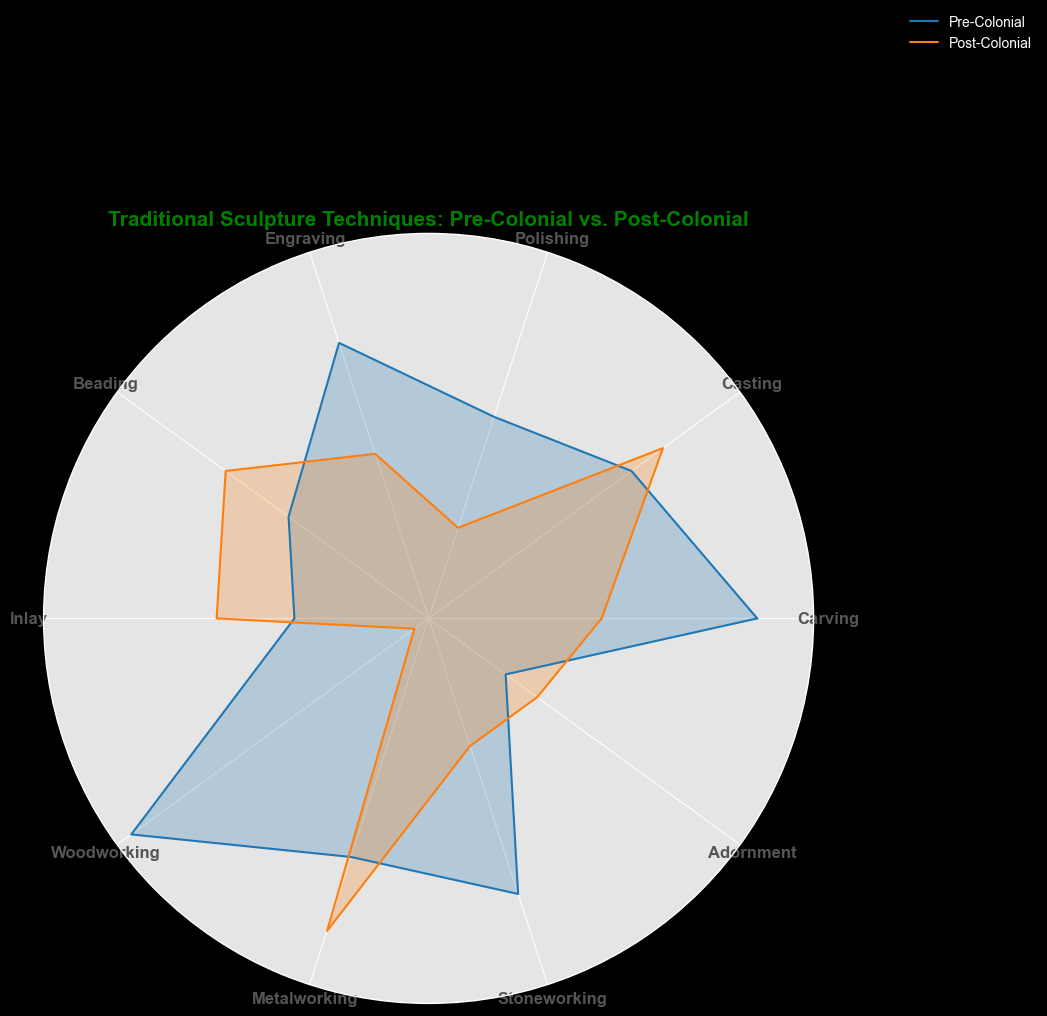Which technique has the greatest difference between the Pre-Colonial and Post-Colonial periods? By examining the radar chart, we compare the values for each technique in both periods. The greatest difference is observed in Woodworking (Pre-Colonial: 95, Post-Colonial: 50), resulting in a difference of 45.
Answer: Woodworking Which technique saw an increase in its value in the Post-Colonial period compared to the Pre-Colonial period? By comparing the values of both periods for each technique, we notice that Casting (Pre-Colonial: 80, Post-Colonial: 85), Beading (Pre-Colonial: 70, Post-Colonial: 80), Inlay (Pre-Colonial: 65, Post-Colonial: 75), Metalworking (Pre-Colonial: 80, Post-Colonial: 90), and Adornment (Pre-Colonial: 60, Post-Colonial: 65) saw increases in the Post-Colonial period.
Answer: Casting, Beading, Inlay, Metalworking, Adornment What is the average value of techniques during the Pre-Colonial period? Sum the values of all techniques during the Pre-Colonial period and divide by the number of techniques: (90+80+75+85+70+65+95+80+85+60)/10 = 78
Answer: 78 For which technique is the Post-Colonial period value the highest? Referring to the radar chart, the highest value in the Post-Colonial period (90) is seen in Metalworking.
Answer: Metalworking Is the value of Polishing higher in the Pre-Colonial or Post-Colonial period? Comparing the values of Polishing in both periods, we see that it is higher in the Pre-Colonial period (75) than in the Post-Colonial period (60).
Answer: Pre-Colonial What's the sum of values for Carving and Engraving in the Pre-Colonial period? Adding the values for Carving (90) and Engraving (85) in the Pre-Colonial period provides: 90 + 85 = 175.
Answer: 175 How many techniques have equal values in both periods? By examining the radar chart, no techniques have equal values in both the Pre-Colonial and Post-Colonial periods.
Answer: 0 Which period has the greater total sum for all techniques combined? Calculate the total sum of values for both the Pre-Colonial and Post-Colonial periods: 
Pre-Colonial: 90 + 80 + 75 + 85 + 70 + 65 + 95 + 80 + 85 + 60 = 785 
Post-Colonial: 70 + 85 + 60 + 70 + 80 + 75 + 50 + 90 + 65 + 65 = 710 
The Pre-Colonial period has a greater total sum.
Answer: Pre-Colonial 